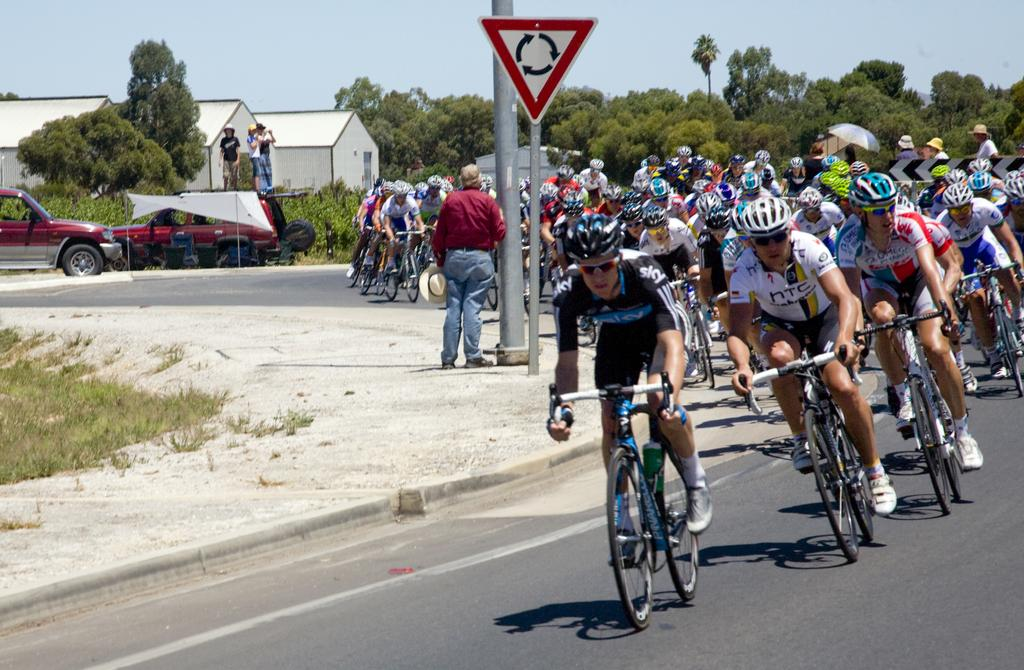What are the people in the image doing? There are people riding bicycles on the road, standing and holding a hat, and standing on a motor vehicle. What structures can be seen in the image? There are buildings visible in the image. What type of vegetation is present in the image? There are trees in the image. What objects can be seen with text or symbols on them? There are sign boards in the image. What vertical structures are present in the image? There are poles in the image. What part of the natural environment is visible in the image? The sky is visible in the image. Can you see any industrial machinery in the image? There is no industrial machinery present in the image. What type of snake can be seen slithering on the ground in the image? There are no snakes present in the image. What kind of fan is visible in the image? There are no fans present in the image. 